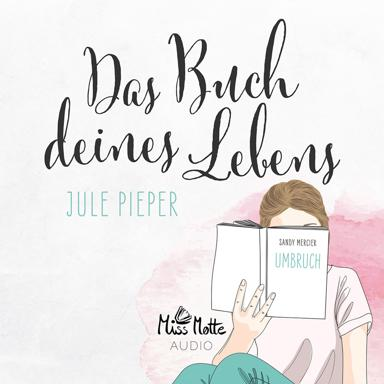What might be the theme of the book the girl is reading? The book titled 'Das Buch deines Lebens' by Jule Pieper and 'UMBRUCH' by Sandy Mercier might explore themes of personal transformation or self-discovery, given the prominence and thoughtful expression of the girl. 